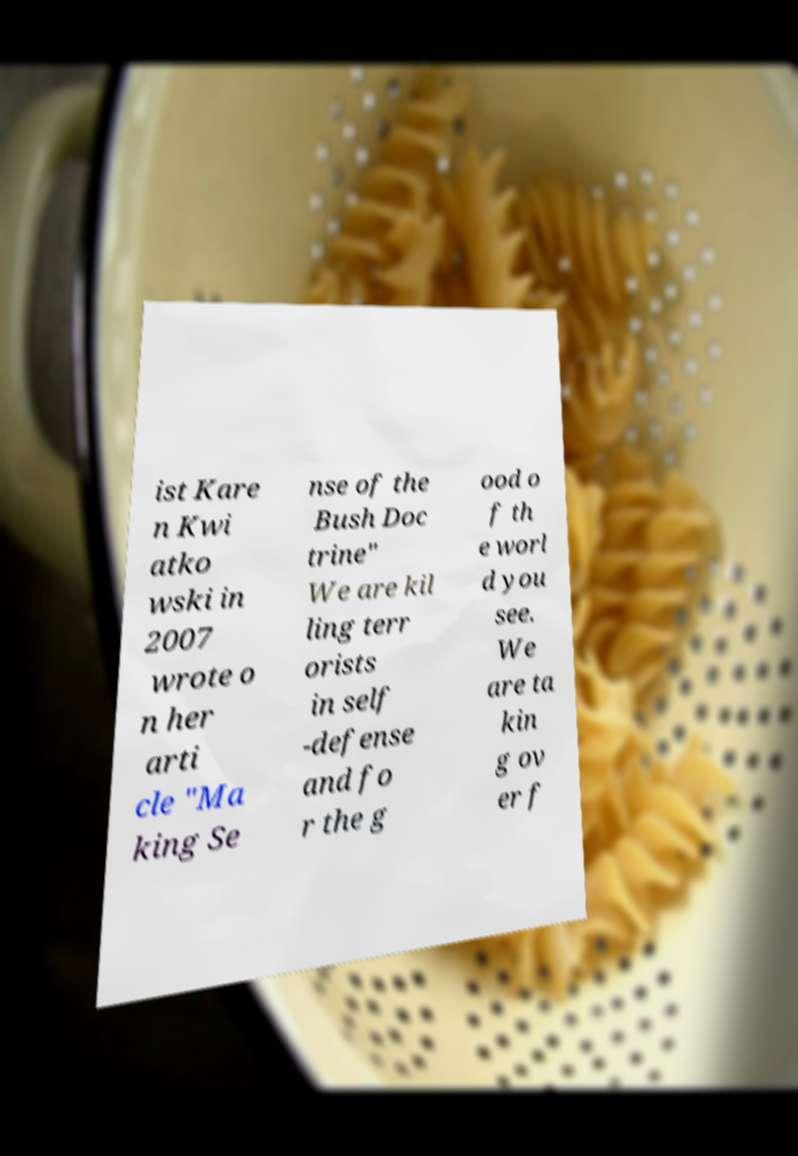Could you extract and type out the text from this image? ist Kare n Kwi atko wski in 2007 wrote o n her arti cle "Ma king Se nse of the Bush Doc trine" We are kil ling terr orists in self -defense and fo r the g ood o f th e worl d you see. We are ta kin g ov er f 